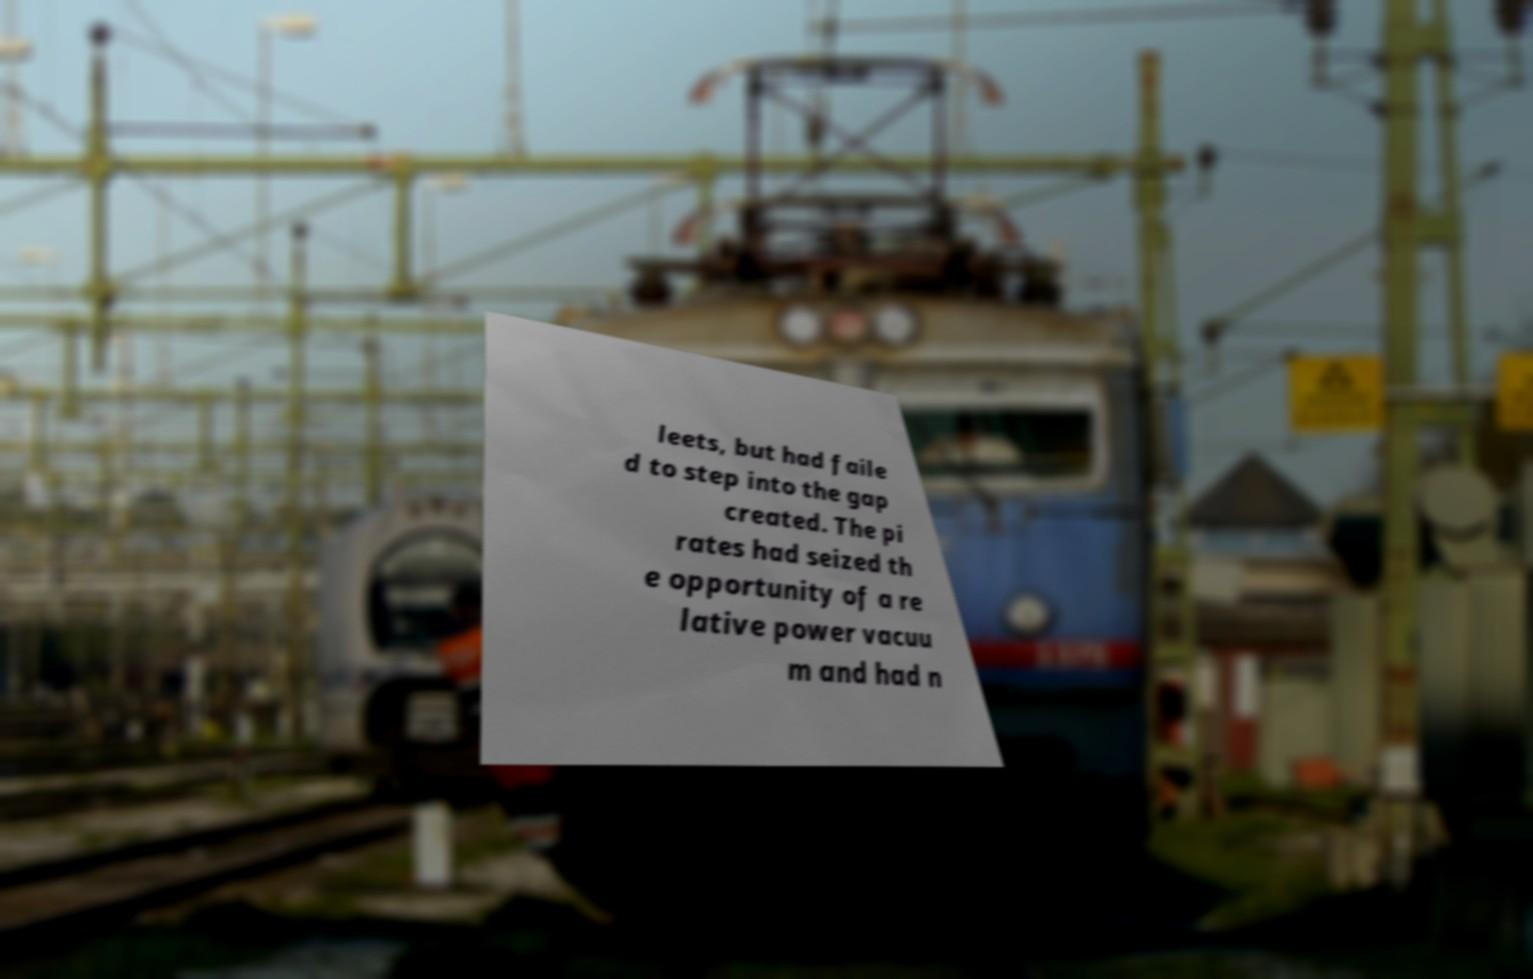What messages or text are displayed in this image? I need them in a readable, typed format. leets, but had faile d to step into the gap created. The pi rates had seized th e opportunity of a re lative power vacuu m and had n 